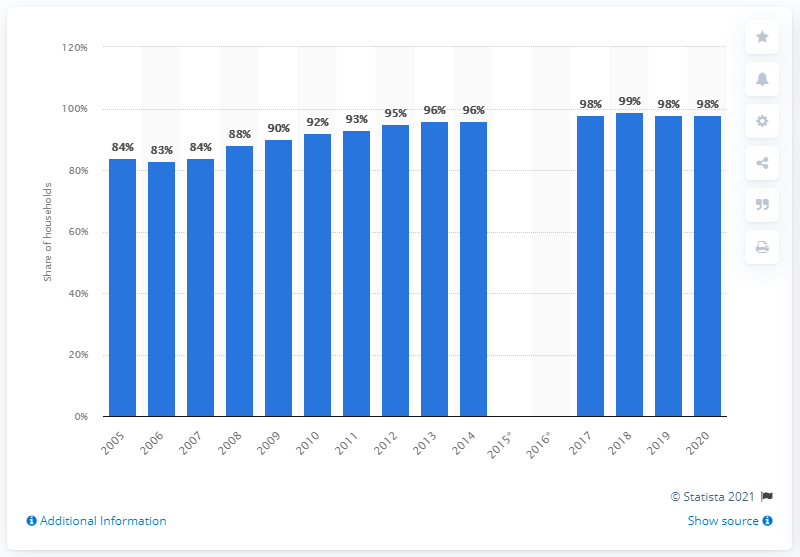Highlight a few significant elements in this photo. In 2020, Iceland was the European country with the highest percentage of households connected to the internet. 